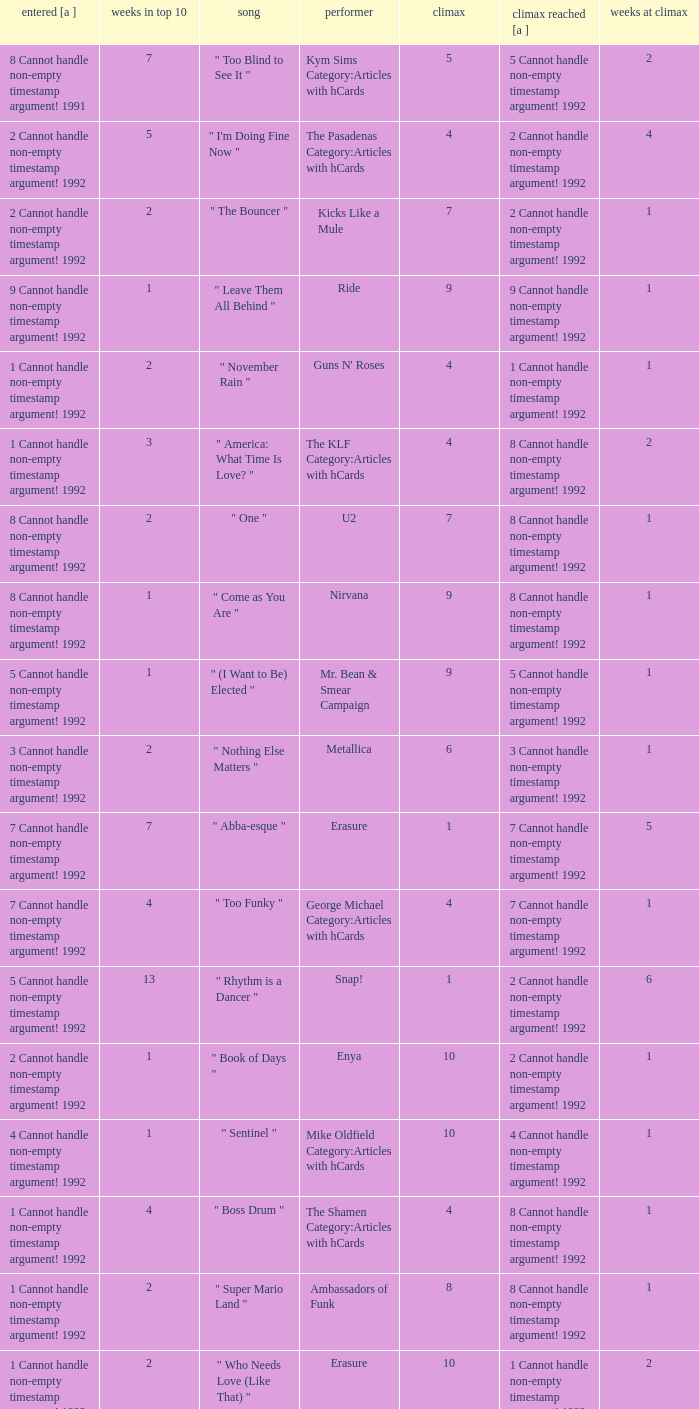If the peak reached is 6 cannot handle non-empty timestamp argument! 1992, what is the entered? 6 Cannot handle non-empty timestamp argument! 1992. 